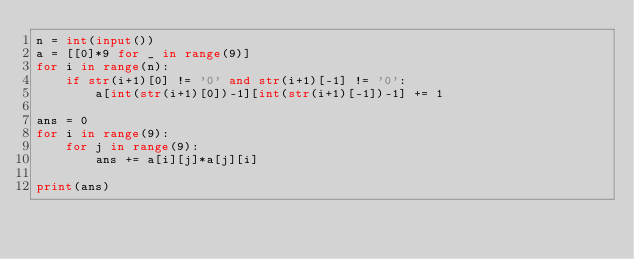<code> <loc_0><loc_0><loc_500><loc_500><_Python_>n = int(input())
a = [[0]*9 for _ in range(9)]
for i in range(n):
    if str(i+1)[0] != '0' and str(i+1)[-1] != '0':
        a[int(str(i+1)[0])-1][int(str(i+1)[-1])-1] += 1
        
ans = 0
for i in range(9):
    for j in range(9):
        ans += a[i][j]*a[j][i]
        
print(ans)</code> 